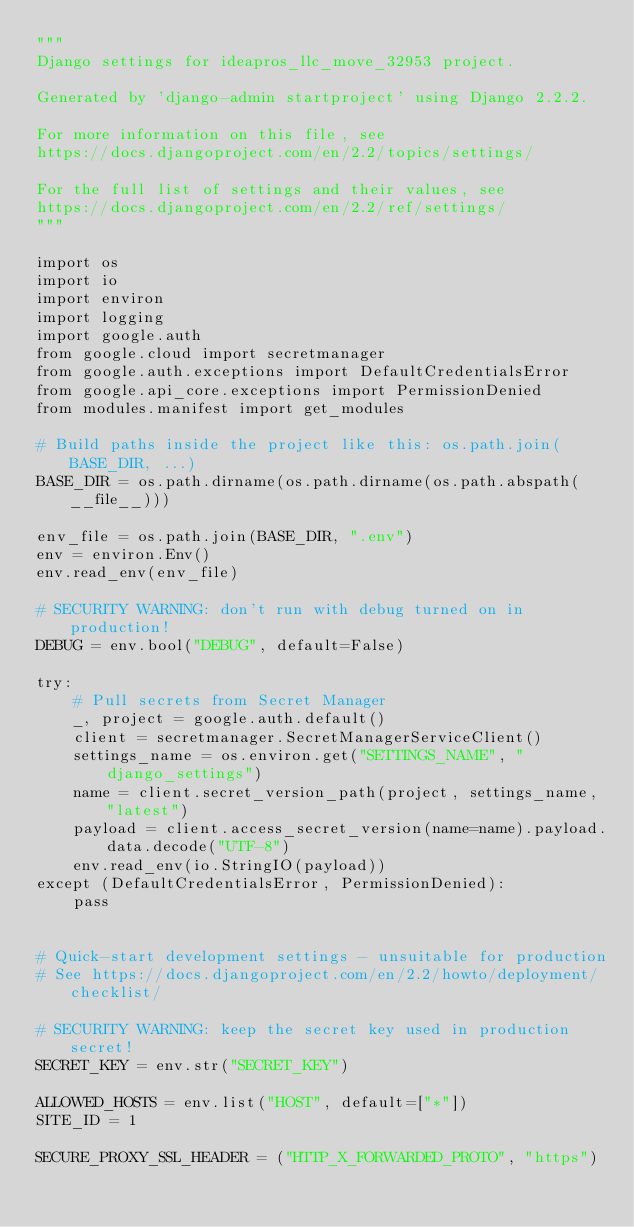<code> <loc_0><loc_0><loc_500><loc_500><_Python_>"""
Django settings for ideapros_llc_move_32953 project.

Generated by 'django-admin startproject' using Django 2.2.2.

For more information on this file, see
https://docs.djangoproject.com/en/2.2/topics/settings/

For the full list of settings and their values, see
https://docs.djangoproject.com/en/2.2/ref/settings/
"""

import os
import io
import environ
import logging
import google.auth
from google.cloud import secretmanager
from google.auth.exceptions import DefaultCredentialsError
from google.api_core.exceptions import PermissionDenied
from modules.manifest import get_modules

# Build paths inside the project like this: os.path.join(BASE_DIR, ...)
BASE_DIR = os.path.dirname(os.path.dirname(os.path.abspath(__file__)))

env_file = os.path.join(BASE_DIR, ".env")
env = environ.Env()
env.read_env(env_file)

# SECURITY WARNING: don't run with debug turned on in production!
DEBUG = env.bool("DEBUG", default=False)

try:
    # Pull secrets from Secret Manager
    _, project = google.auth.default()
    client = secretmanager.SecretManagerServiceClient()
    settings_name = os.environ.get("SETTINGS_NAME", "django_settings")
    name = client.secret_version_path(project, settings_name, "latest")
    payload = client.access_secret_version(name=name).payload.data.decode("UTF-8")
    env.read_env(io.StringIO(payload))
except (DefaultCredentialsError, PermissionDenied):
    pass


# Quick-start development settings - unsuitable for production
# See https://docs.djangoproject.com/en/2.2/howto/deployment/checklist/

# SECURITY WARNING: keep the secret key used in production secret!
SECRET_KEY = env.str("SECRET_KEY")

ALLOWED_HOSTS = env.list("HOST", default=["*"])
SITE_ID = 1

SECURE_PROXY_SSL_HEADER = ("HTTP_X_FORWARDED_PROTO", "https")</code> 